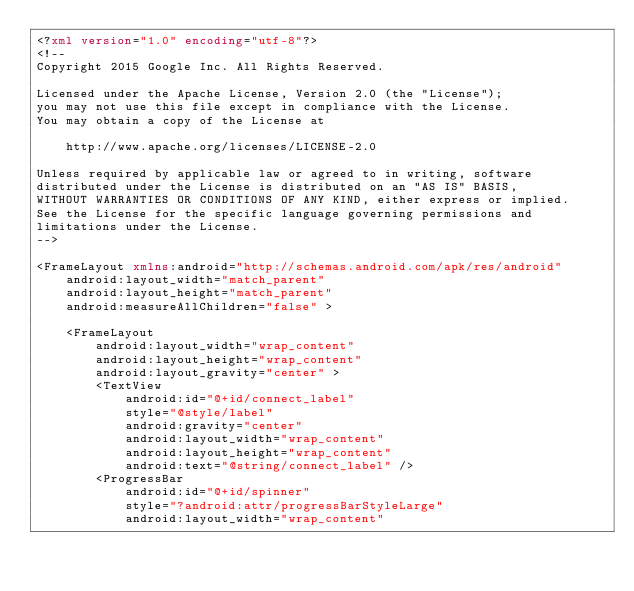<code> <loc_0><loc_0><loc_500><loc_500><_XML_><?xml version="1.0" encoding="utf-8"?>
<!--
Copyright 2015 Google Inc. All Rights Reserved.

Licensed under the Apache License, Version 2.0 (the "License");
you may not use this file except in compliance with the License.
You may obtain a copy of the License at

    http://www.apache.org/licenses/LICENSE-2.0

Unless required by applicable law or agreed to in writing, software
distributed under the License is distributed on an "AS IS" BASIS,
WITHOUT WARRANTIES OR CONDITIONS OF ANY KIND, either express or implied.
See the License for the specific language governing permissions and
limitations under the License.
-->

<FrameLayout xmlns:android="http://schemas.android.com/apk/res/android"
    android:layout_width="match_parent"
    android:layout_height="match_parent"
    android:measureAllChildren="false" >

    <FrameLayout
        android:layout_width="wrap_content"
        android:layout_height="wrap_content"
        android:layout_gravity="center" >
        <TextView
            android:id="@+id/connect_label"
            style="@style/label"
            android:gravity="center"
            android:layout_width="wrap_content"
            android:layout_height="wrap_content"
            android:text="@string/connect_label" />
        <ProgressBar
            android:id="@+id/spinner"
            style="?android:attr/progressBarStyleLarge"
            android:layout_width="wrap_content"</code> 